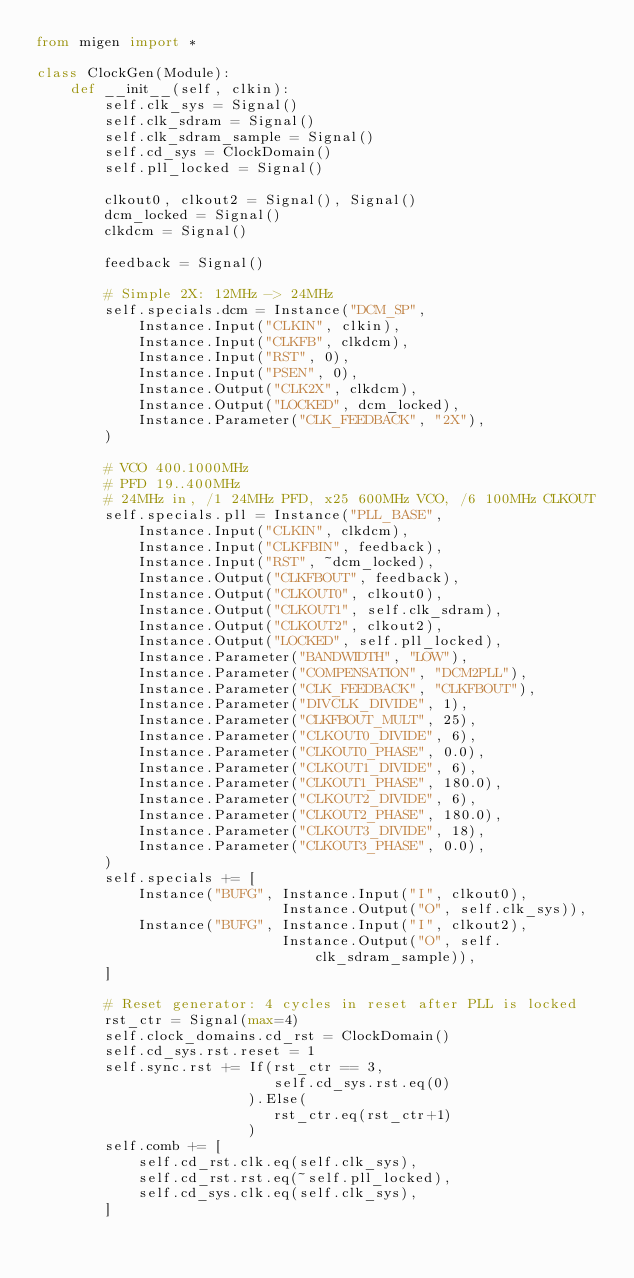<code> <loc_0><loc_0><loc_500><loc_500><_Python_>from migen import *

class ClockGen(Module):
    def __init__(self, clkin):
        self.clk_sys = Signal()
        self.clk_sdram = Signal()
        self.clk_sdram_sample = Signal()
        self.cd_sys = ClockDomain()
        self.pll_locked = Signal()

        clkout0, clkout2 = Signal(), Signal()
        dcm_locked = Signal()
        clkdcm = Signal()

        feedback = Signal()

        # Simple 2X: 12MHz -> 24MHz
        self.specials.dcm = Instance("DCM_SP",
            Instance.Input("CLKIN", clkin),
            Instance.Input("CLKFB", clkdcm),
            Instance.Input("RST", 0),
            Instance.Input("PSEN", 0),
            Instance.Output("CLK2X", clkdcm),
            Instance.Output("LOCKED", dcm_locked),
            Instance.Parameter("CLK_FEEDBACK", "2X"),
        )

        # VCO 400.1000MHz
        # PFD 19..400MHz
        # 24MHz in, /1 24MHz PFD, x25 600MHz VCO, /6 100MHz CLKOUT
        self.specials.pll = Instance("PLL_BASE",
            Instance.Input("CLKIN", clkdcm),
            Instance.Input("CLKFBIN", feedback),
            Instance.Input("RST", ~dcm_locked),
            Instance.Output("CLKFBOUT", feedback),
            Instance.Output("CLKOUT0", clkout0),
            Instance.Output("CLKOUT1", self.clk_sdram),
            Instance.Output("CLKOUT2", clkout2),
            Instance.Output("LOCKED", self.pll_locked),
            Instance.Parameter("BANDWIDTH", "LOW"),
            Instance.Parameter("COMPENSATION", "DCM2PLL"),
            Instance.Parameter("CLK_FEEDBACK", "CLKFBOUT"),
            Instance.Parameter("DIVCLK_DIVIDE", 1),
            Instance.Parameter("CLKFBOUT_MULT", 25),
            Instance.Parameter("CLKOUT0_DIVIDE", 6),
            Instance.Parameter("CLKOUT0_PHASE", 0.0),
            Instance.Parameter("CLKOUT1_DIVIDE", 6),
            Instance.Parameter("CLKOUT1_PHASE", 180.0),
            Instance.Parameter("CLKOUT2_DIVIDE", 6),
            Instance.Parameter("CLKOUT2_PHASE", 180.0),
            Instance.Parameter("CLKOUT3_DIVIDE", 18),
            Instance.Parameter("CLKOUT3_PHASE", 0.0),
        )
        self.specials += [
            Instance("BUFG", Instance.Input("I", clkout0),
                             Instance.Output("O", self.clk_sys)),
            Instance("BUFG", Instance.Input("I", clkout2),
                             Instance.Output("O", self.clk_sdram_sample)),
        ]

        # Reset generator: 4 cycles in reset after PLL is locked
        rst_ctr = Signal(max=4)
        self.clock_domains.cd_rst = ClockDomain()
        self.cd_sys.rst.reset = 1
        self.sync.rst += If(rst_ctr == 3,
                            self.cd_sys.rst.eq(0)
                         ).Else(
                            rst_ctr.eq(rst_ctr+1)
                         )
        self.comb += [
            self.cd_rst.clk.eq(self.clk_sys),
            self.cd_rst.rst.eq(~self.pll_locked),
            self.cd_sys.clk.eq(self.clk_sys),
        ]
</code> 